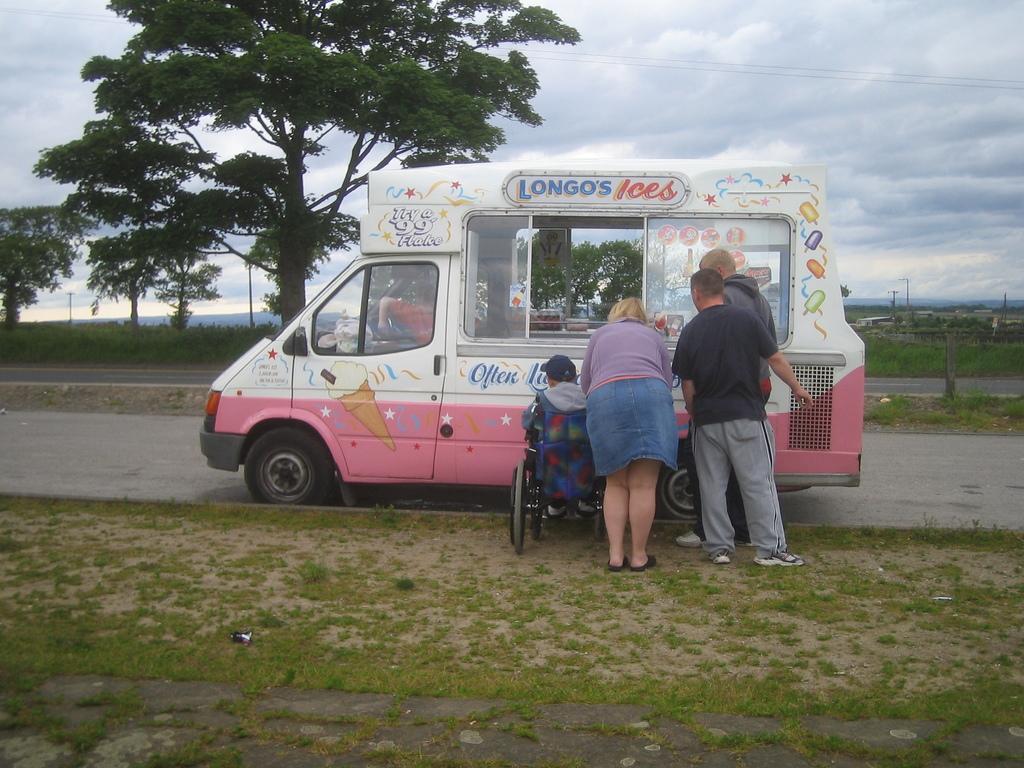In one or two sentences, can you explain what this image depicts? A man in a wheel chair, a woman and two other men are standing near a mobile ice cream vendor. The vehicle is parked beside a road. There are some trees in the background. The sky is cloudy. 